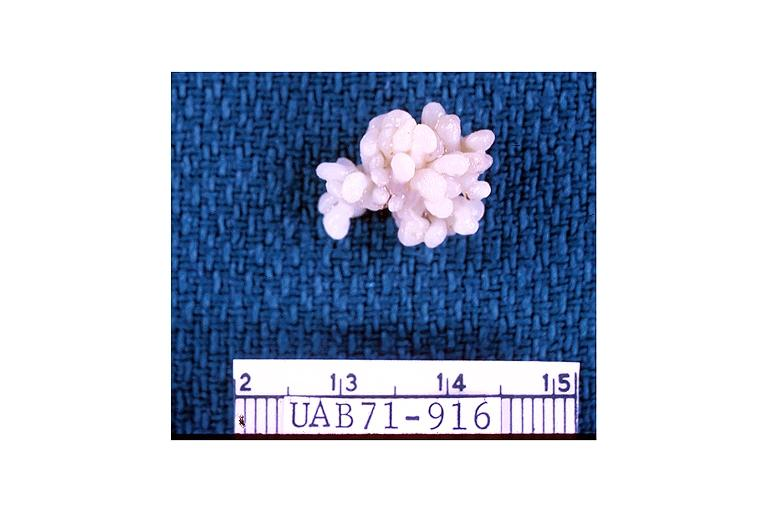does this image show papilloma?
Answer the question using a single word or phrase. Yes 